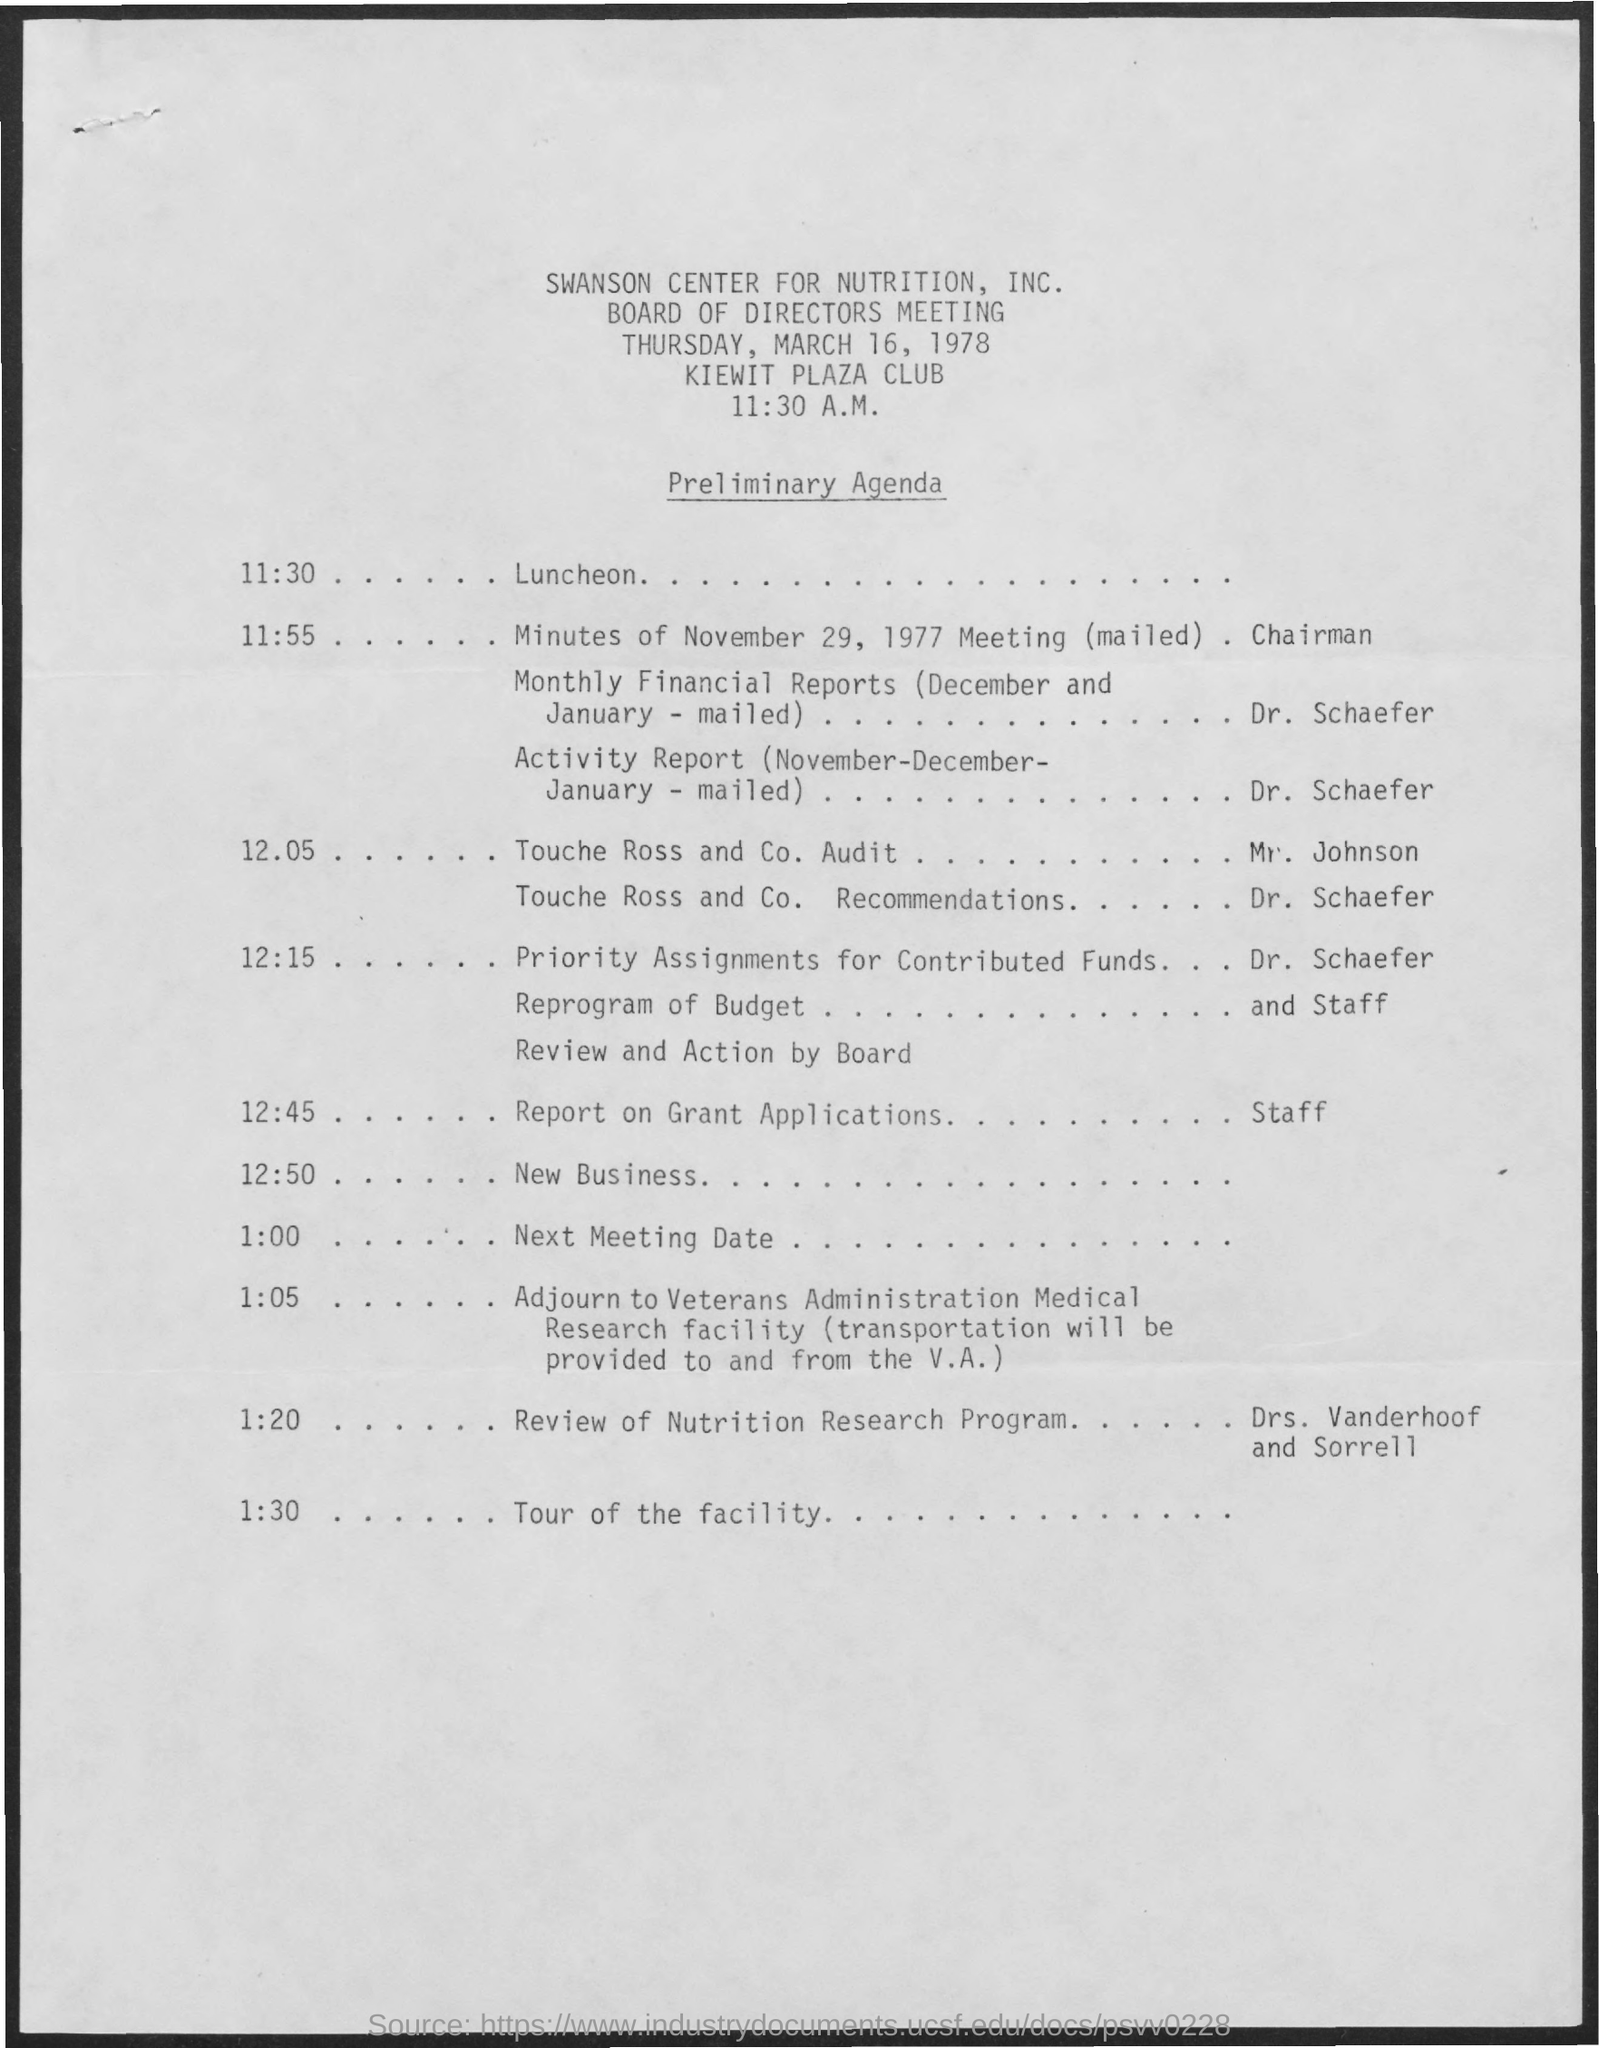What is the name of the meeting ?
Keep it short and to the point. Board of directors meeting. What is the name of the club mentioned ?
Ensure brevity in your answer.  Kiewit plaza club. What is the schedule at the time of 11:30 ?
Your response must be concise. Luncheon. 